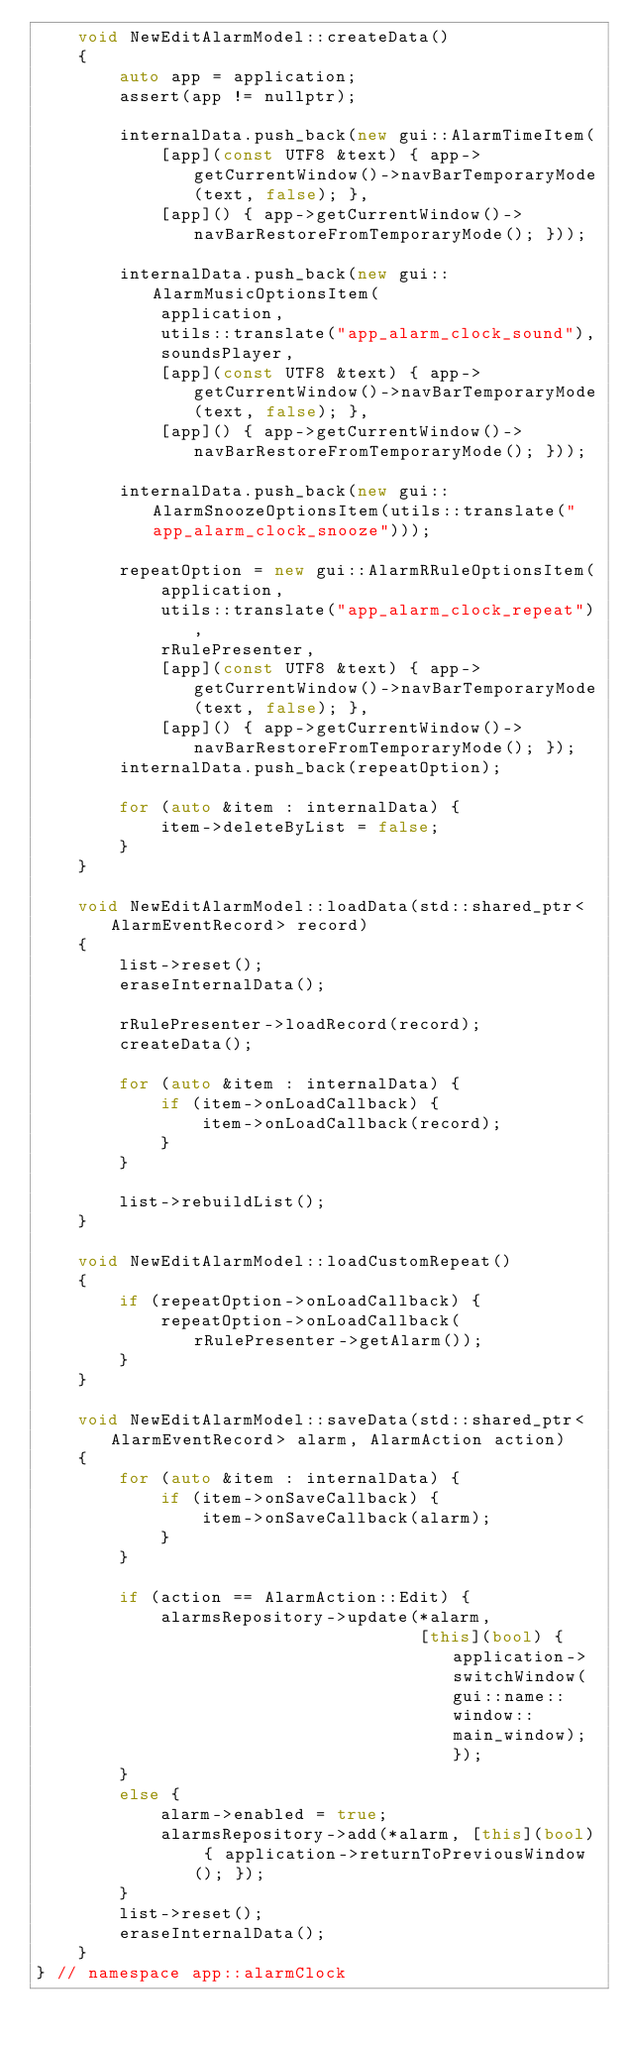<code> <loc_0><loc_0><loc_500><loc_500><_C++_>    void NewEditAlarmModel::createData()
    {
        auto app = application;
        assert(app != nullptr);

        internalData.push_back(new gui::AlarmTimeItem(
            [app](const UTF8 &text) { app->getCurrentWindow()->navBarTemporaryMode(text, false); },
            [app]() { app->getCurrentWindow()->navBarRestoreFromTemporaryMode(); }));

        internalData.push_back(new gui::AlarmMusicOptionsItem(
            application,
            utils::translate("app_alarm_clock_sound"),
            soundsPlayer,
            [app](const UTF8 &text) { app->getCurrentWindow()->navBarTemporaryMode(text, false); },
            [app]() { app->getCurrentWindow()->navBarRestoreFromTemporaryMode(); }));

        internalData.push_back(new gui::AlarmSnoozeOptionsItem(utils::translate("app_alarm_clock_snooze")));

        repeatOption = new gui::AlarmRRuleOptionsItem(
            application,
            utils::translate("app_alarm_clock_repeat"),
            rRulePresenter,
            [app](const UTF8 &text) { app->getCurrentWindow()->navBarTemporaryMode(text, false); },
            [app]() { app->getCurrentWindow()->navBarRestoreFromTemporaryMode(); });
        internalData.push_back(repeatOption);

        for (auto &item : internalData) {
            item->deleteByList = false;
        }
    }

    void NewEditAlarmModel::loadData(std::shared_ptr<AlarmEventRecord> record)
    {
        list->reset();
        eraseInternalData();

        rRulePresenter->loadRecord(record);
        createData();

        for (auto &item : internalData) {
            if (item->onLoadCallback) {
                item->onLoadCallback(record);
            }
        }

        list->rebuildList();
    }

    void NewEditAlarmModel::loadCustomRepeat()
    {
        if (repeatOption->onLoadCallback) {
            repeatOption->onLoadCallback(rRulePresenter->getAlarm());
        }
    }

    void NewEditAlarmModel::saveData(std::shared_ptr<AlarmEventRecord> alarm, AlarmAction action)
    {
        for (auto &item : internalData) {
            if (item->onSaveCallback) {
                item->onSaveCallback(alarm);
            }
        }

        if (action == AlarmAction::Edit) {
            alarmsRepository->update(*alarm,
                                     [this](bool) { application->switchWindow(gui::name::window::main_window); });
        }
        else {
            alarm->enabled = true;
            alarmsRepository->add(*alarm, [this](bool) { application->returnToPreviousWindow(); });
        }
        list->reset();
        eraseInternalData();
    }
} // namespace app::alarmClock
</code> 